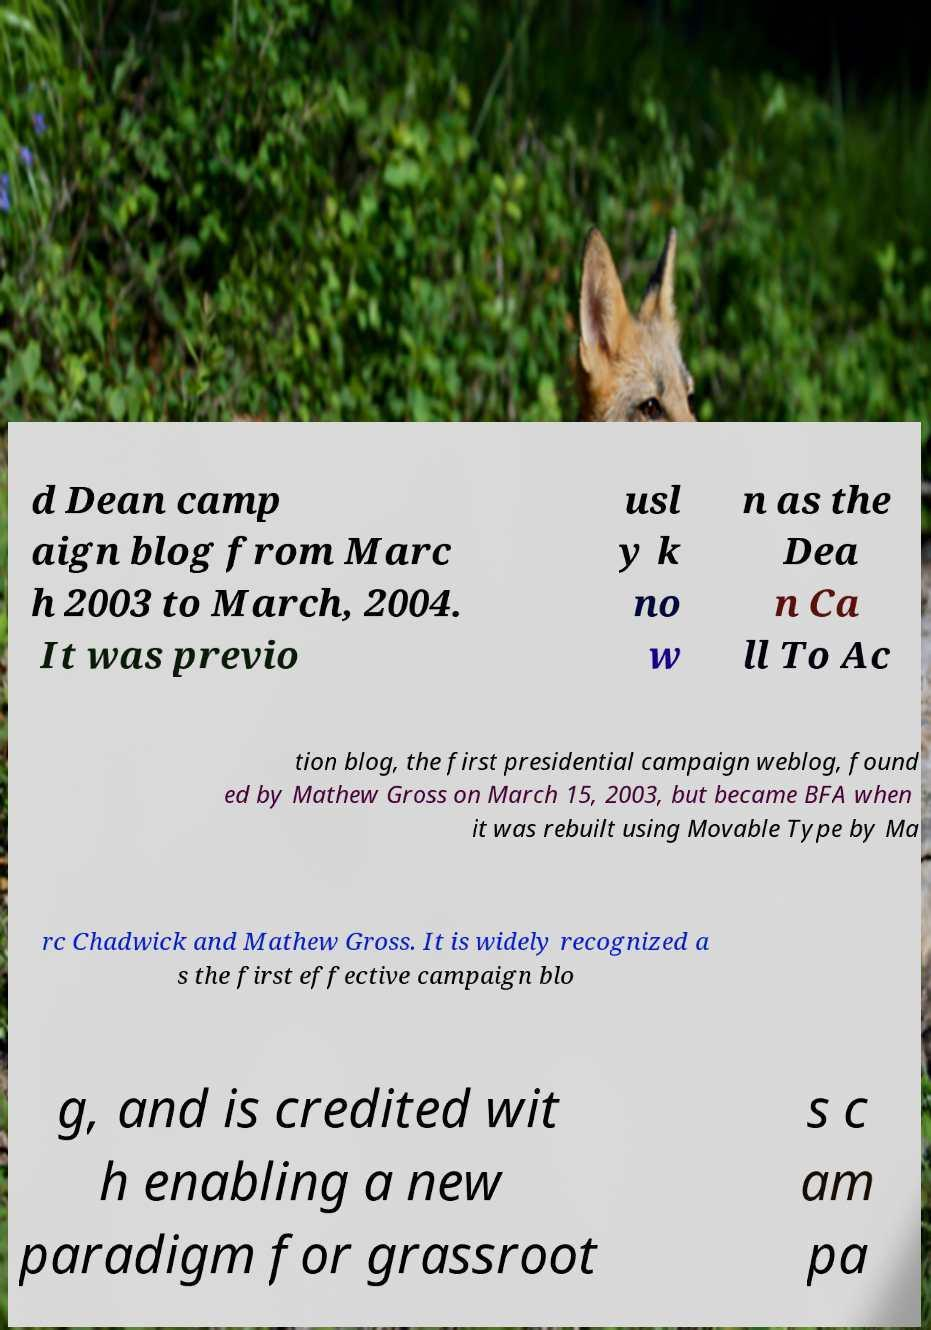I need the written content from this picture converted into text. Can you do that? d Dean camp aign blog from Marc h 2003 to March, 2004. It was previo usl y k no w n as the Dea n Ca ll To Ac tion blog, the first presidential campaign weblog, found ed by Mathew Gross on March 15, 2003, but became BFA when it was rebuilt using Movable Type by Ma rc Chadwick and Mathew Gross. It is widely recognized a s the first effective campaign blo g, and is credited wit h enabling a new paradigm for grassroot s c am pa 